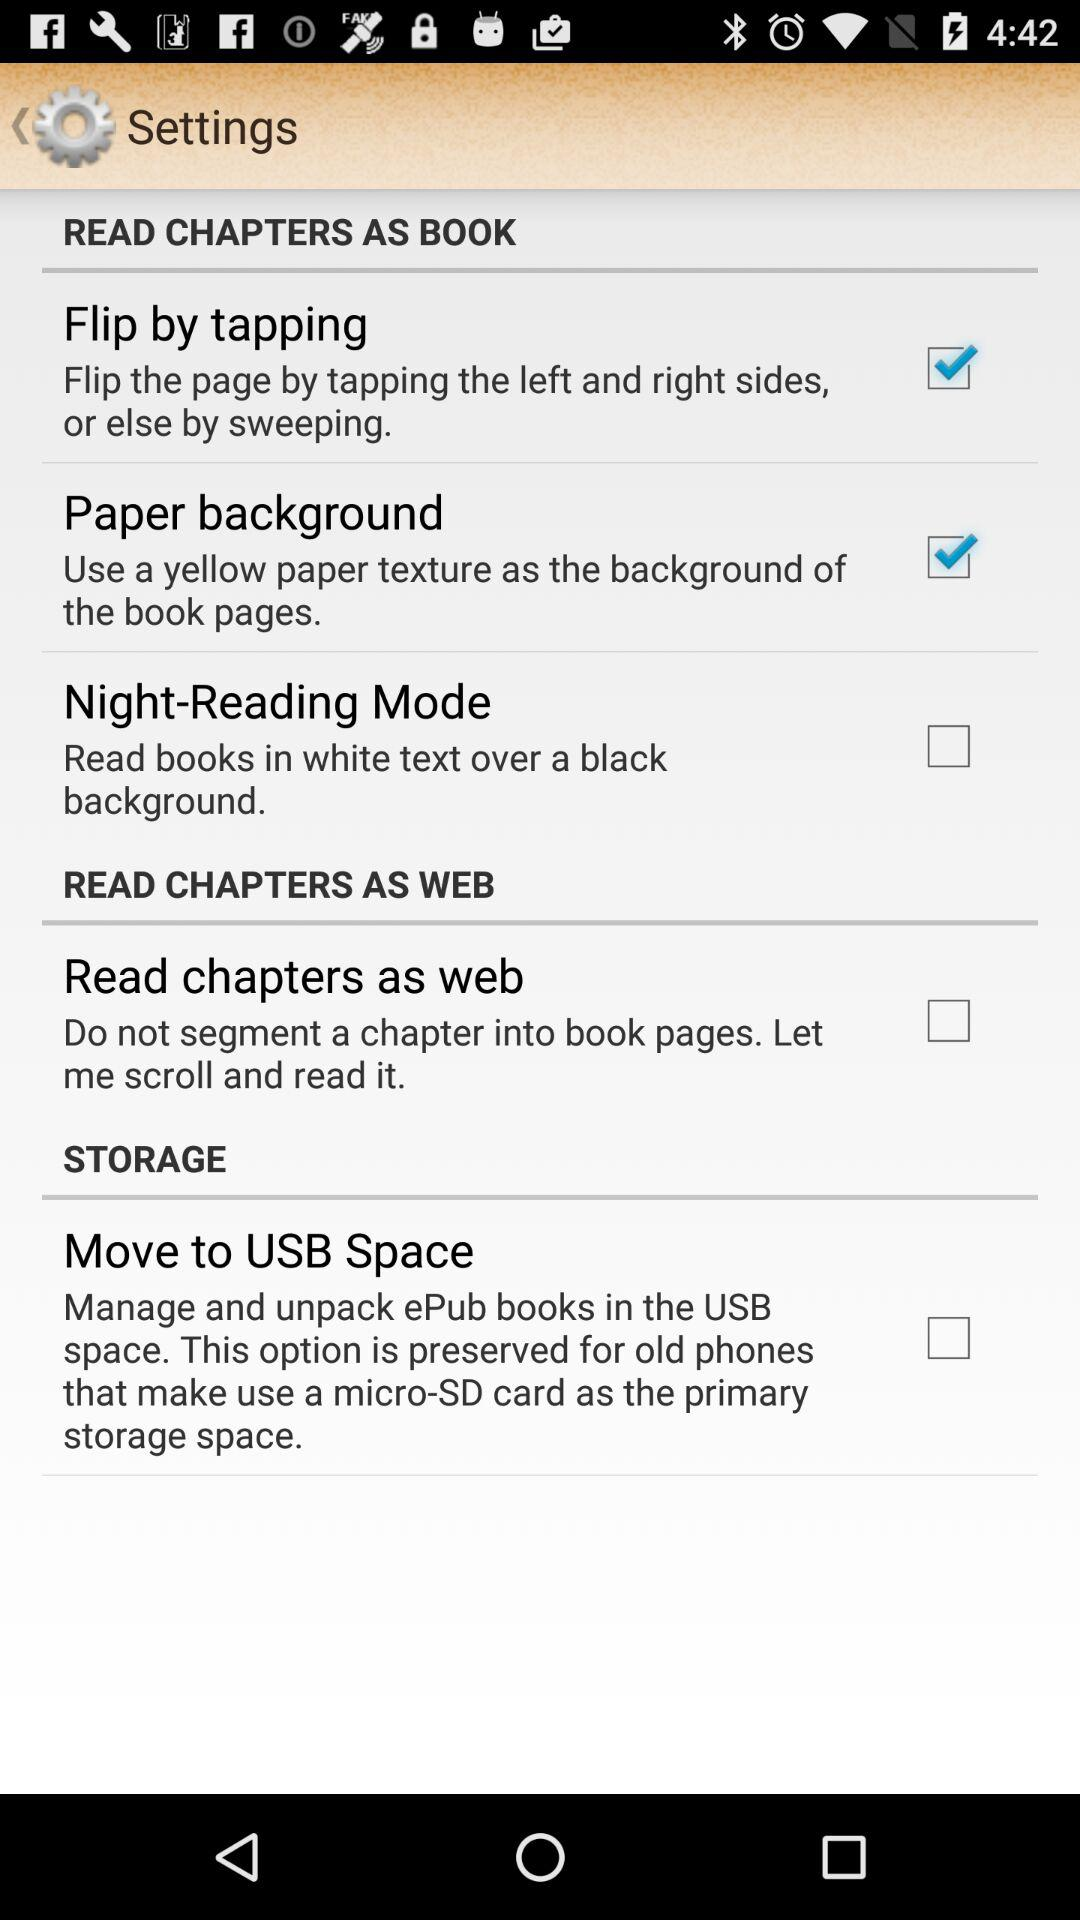What is the status of the Move to USB Space? The status of the Move to USB Space is unchecked. 